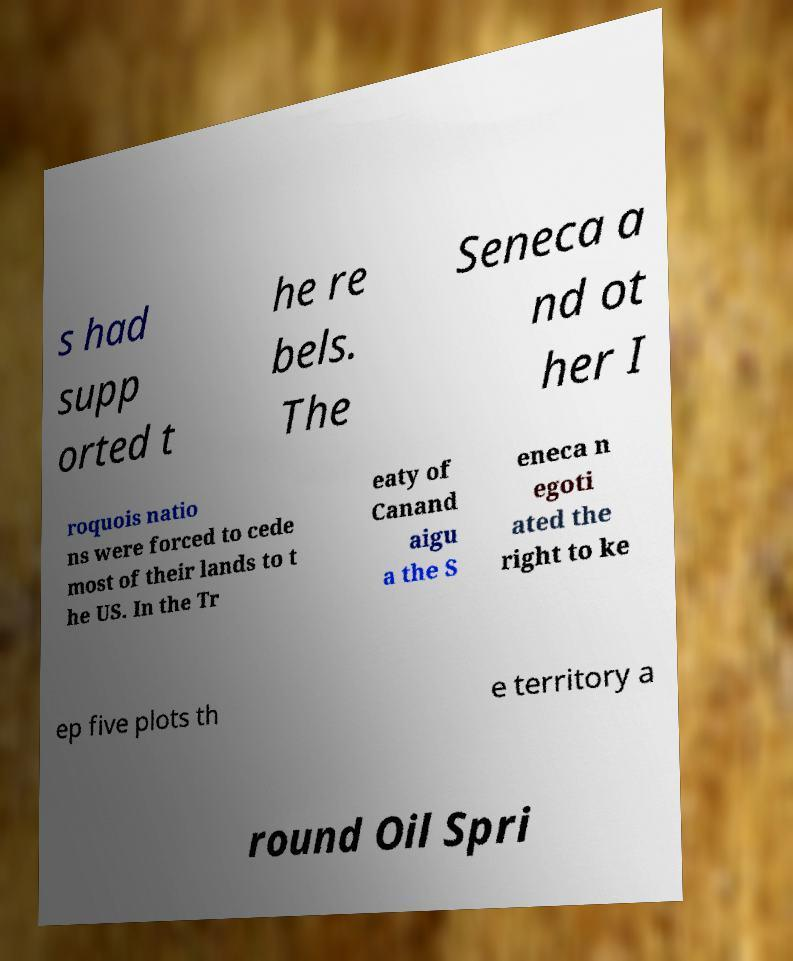Please read and relay the text visible in this image. What does it say? s had supp orted t he re bels. The Seneca a nd ot her I roquois natio ns were forced to cede most of their lands to t he US. In the Tr eaty of Canand aigu a the S eneca n egoti ated the right to ke ep five plots th e territory a round Oil Spri 